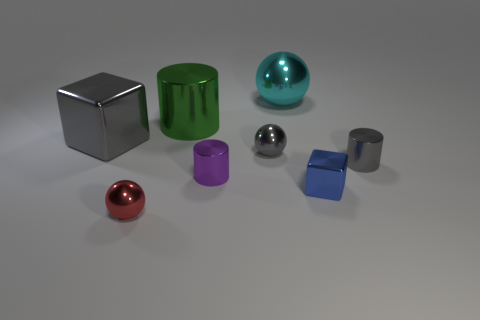Subtract all small metallic balls. How many balls are left? 1 Add 1 small red rubber cylinders. How many objects exist? 9 Subtract all red spheres. How many spheres are left? 2 Subtract all balls. How many objects are left? 5 Subtract 1 cylinders. How many cylinders are left? 2 Subtract all cyan cylinders. Subtract all purple spheres. How many cylinders are left? 3 Subtract all large metallic cubes. Subtract all gray spheres. How many objects are left? 6 Add 3 tiny shiny blocks. How many tiny shiny blocks are left? 4 Add 4 large green metallic spheres. How many large green metallic spheres exist? 4 Subtract 0 blue spheres. How many objects are left? 8 